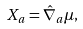Convert formula to latex. <formula><loc_0><loc_0><loc_500><loc_500>X _ { a } = \hat { \nabla } _ { a } \mu ,</formula> 